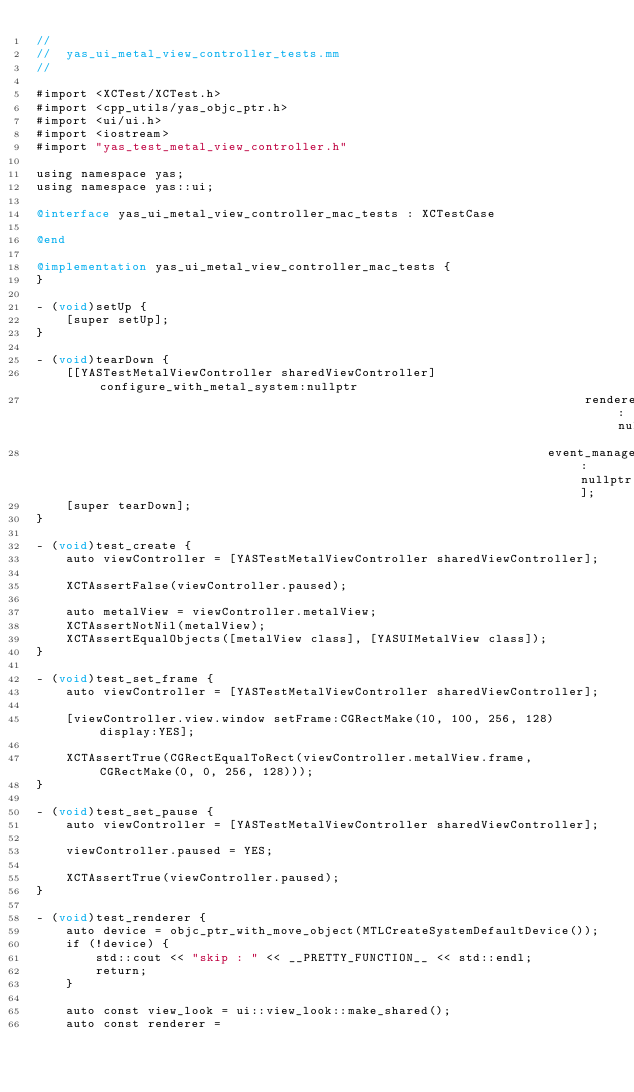Convert code to text. <code><loc_0><loc_0><loc_500><loc_500><_ObjectiveC_>//
//  yas_ui_metal_view_controller_tests.mm
//

#import <XCTest/XCTest.h>
#import <cpp_utils/yas_objc_ptr.h>
#import <ui/ui.h>
#import <iostream>
#import "yas_test_metal_view_controller.h"

using namespace yas;
using namespace yas::ui;

@interface yas_ui_metal_view_controller_mac_tests : XCTestCase

@end

@implementation yas_ui_metal_view_controller_mac_tests {
}

- (void)setUp {
    [super setUp];
}

- (void)tearDown {
    [[YASTestMetalViewController sharedViewController] configure_with_metal_system:nullptr
                                                                          renderer:nullptr
                                                                     event_manager:nullptr];
    [super tearDown];
}

- (void)test_create {
    auto viewController = [YASTestMetalViewController sharedViewController];

    XCTAssertFalse(viewController.paused);

    auto metalView = viewController.metalView;
    XCTAssertNotNil(metalView);
    XCTAssertEqualObjects([metalView class], [YASUIMetalView class]);
}

- (void)test_set_frame {
    auto viewController = [YASTestMetalViewController sharedViewController];

    [viewController.view.window setFrame:CGRectMake(10, 100, 256, 128) display:YES];

    XCTAssertTrue(CGRectEqualToRect(viewController.metalView.frame, CGRectMake(0, 0, 256, 128)));
}

- (void)test_set_pause {
    auto viewController = [YASTestMetalViewController sharedViewController];

    viewController.paused = YES;

    XCTAssertTrue(viewController.paused);
}

- (void)test_renderer {
    auto device = objc_ptr_with_move_object(MTLCreateSystemDefaultDevice());
    if (!device) {
        std::cout << "skip : " << __PRETTY_FUNCTION__ << std::endl;
        return;
    }

    auto const view_look = ui::view_look::make_shared();
    auto const renderer =</code> 